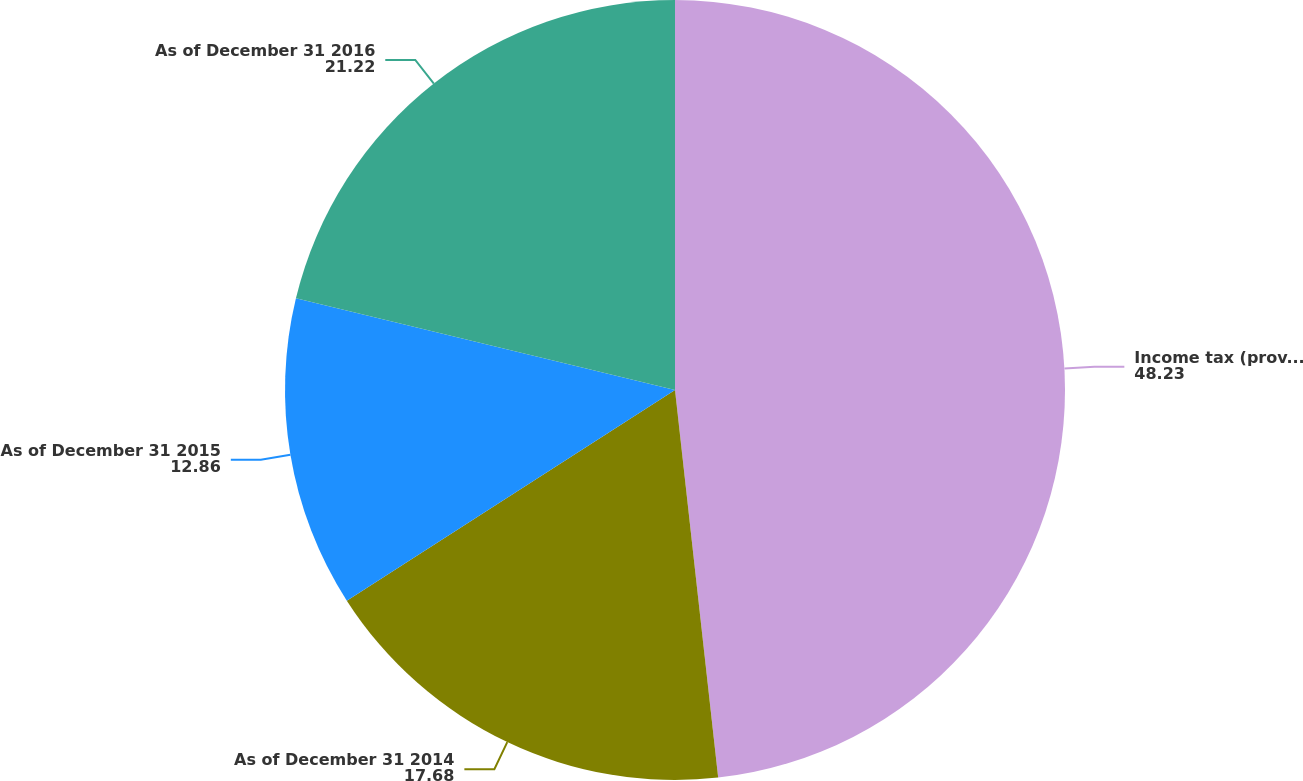Convert chart. <chart><loc_0><loc_0><loc_500><loc_500><pie_chart><fcel>Income tax (provision) benefit<fcel>As of December 31 2014<fcel>As of December 31 2015<fcel>As of December 31 2016<nl><fcel>48.23%<fcel>17.68%<fcel>12.86%<fcel>21.22%<nl></chart> 